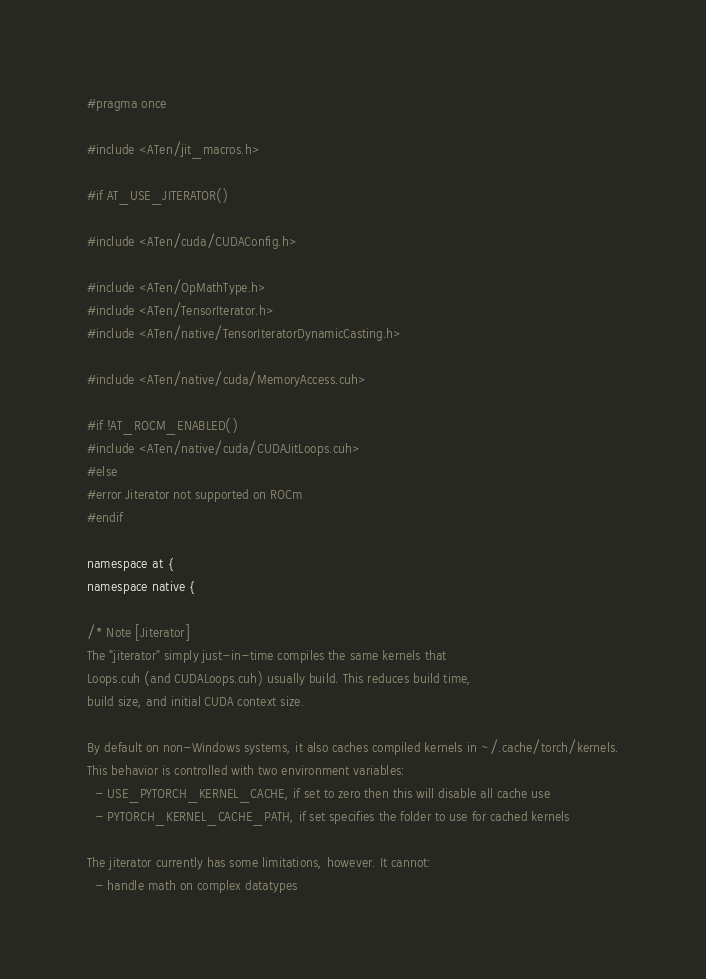Convert code to text. <code><loc_0><loc_0><loc_500><loc_500><_Cuda_>#pragma once

#include <ATen/jit_macros.h>

#if AT_USE_JITERATOR()

#include <ATen/cuda/CUDAConfig.h>

#include <ATen/OpMathType.h>
#include <ATen/TensorIterator.h>
#include <ATen/native/TensorIteratorDynamicCasting.h>

#include <ATen/native/cuda/MemoryAccess.cuh>

#if !AT_ROCM_ENABLED()
#include <ATen/native/cuda/CUDAJitLoops.cuh>
#else
#error Jiterator not supported on ROCm
#endif

namespace at {
namespace native {

/* Note [Jiterator]
The "jiterator" simply just-in-time compiles the same kernels that
Loops.cuh (and CUDALoops.cuh) usually build. This reduces build time,
build size, and initial CUDA context size.

By default on non-Windows systems, it also caches compiled kernels in ~/.cache/torch/kernels.
This behavior is controlled with two environment variables:
  - USE_PYTORCH_KERNEL_CACHE, if set to zero then this will disable all cache use
  - PYTORCH_KERNEL_CACHE_PATH, if set specifies the folder to use for cached kernels

The jiterator currently has some limitations, however. It cannot:
  - handle math on complex datatypes</code> 